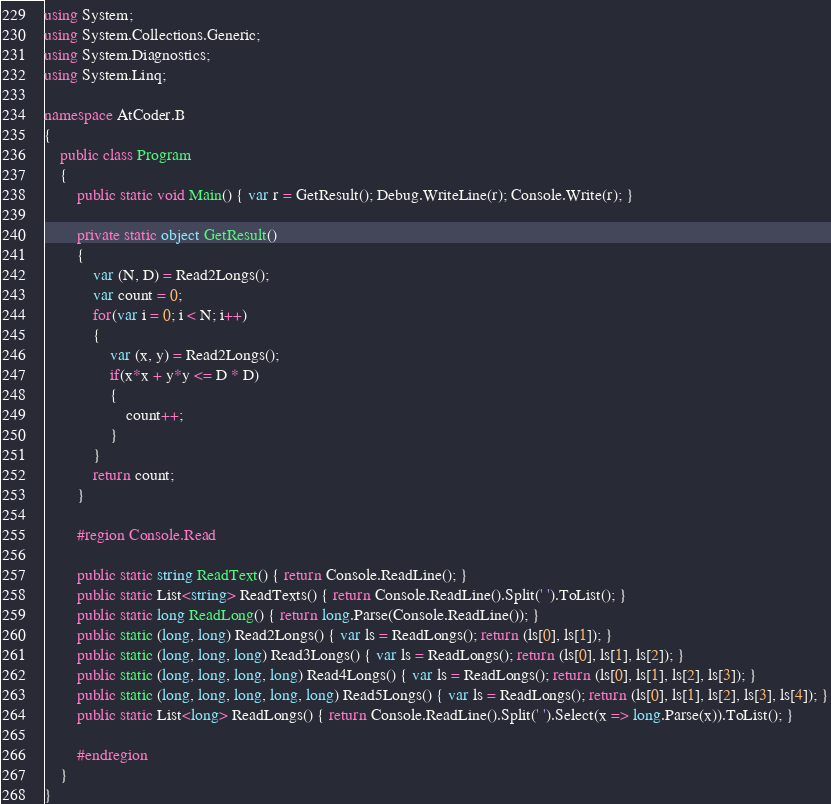Convert code to text. <code><loc_0><loc_0><loc_500><loc_500><_C#_>using System;
using System.Collections.Generic;
using System.Diagnostics;
using System.Linq;

namespace AtCoder.B
{
    public class Program
    {
        public static void Main() { var r = GetResult(); Debug.WriteLine(r); Console.Write(r); }

        private static object GetResult()
        {
            var (N, D) = Read2Longs();
            var count = 0;
            for(var i = 0; i < N; i++)
            {
                var (x, y) = Read2Longs();
                if(x*x + y*y <= D * D)
                {
                    count++;
                }
            }
            return count;
        }

        #region Console.Read

        public static string ReadText() { return Console.ReadLine(); }
        public static List<string> ReadTexts() { return Console.ReadLine().Split(' ').ToList(); }
        public static long ReadLong() { return long.Parse(Console.ReadLine()); }
        public static (long, long) Read2Longs() { var ls = ReadLongs(); return (ls[0], ls[1]); }
        public static (long, long, long) Read3Longs() { var ls = ReadLongs(); return (ls[0], ls[1], ls[2]); }
        public static (long, long, long, long) Read4Longs() { var ls = ReadLongs(); return (ls[0], ls[1], ls[2], ls[3]); }
        public static (long, long, long, long, long) Read5Longs() { var ls = ReadLongs(); return (ls[0], ls[1], ls[2], ls[3], ls[4]); }
        public static List<long> ReadLongs() { return Console.ReadLine().Split(' ').Select(x => long.Parse(x)).ToList(); }

        #endregion
    }
}
</code> 